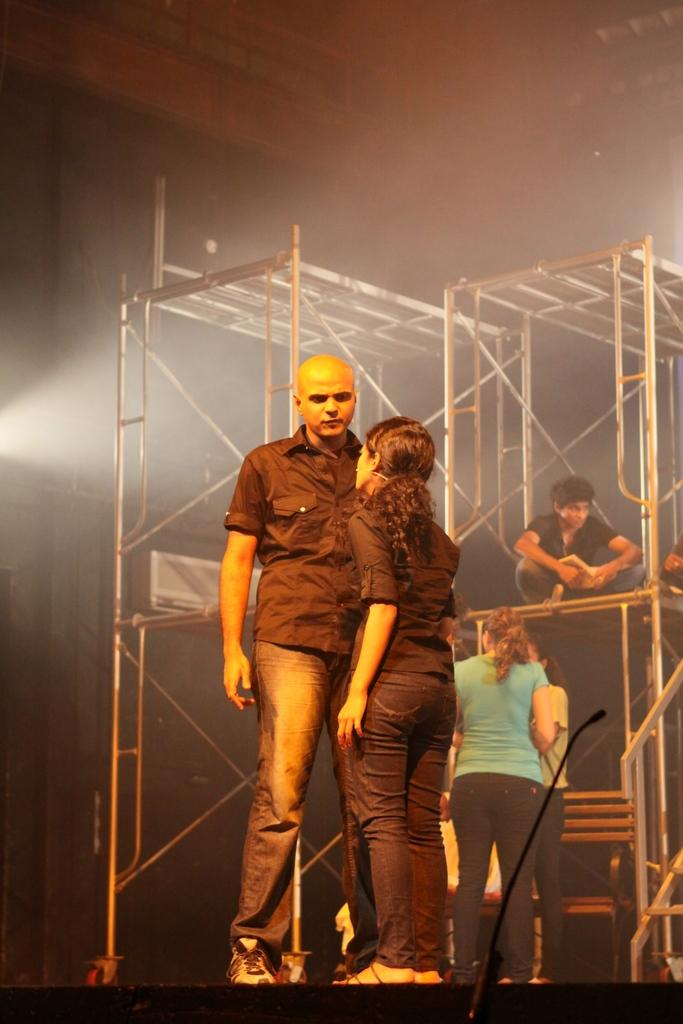How many people are in the image? There are people in the image, but the exact number is not specified. What is the main object in the image? There is a bench in the image. What is the purpose of the microphone (mike) in the image? The presence of a microphone suggests that the people in the image might be engaged in a public speaking event or performance. What are the stands in the image used for? The stands in the image are likely used to support or display other objects or equipment. What can be inferred about the lighting conditions in the image? The background of the image is dark, which might suggest that the image was taken in low light conditions or at night. Can you measure the distance between the stars in the image? There are no stars present in the image, so it is not possible to measure the distance between them. 